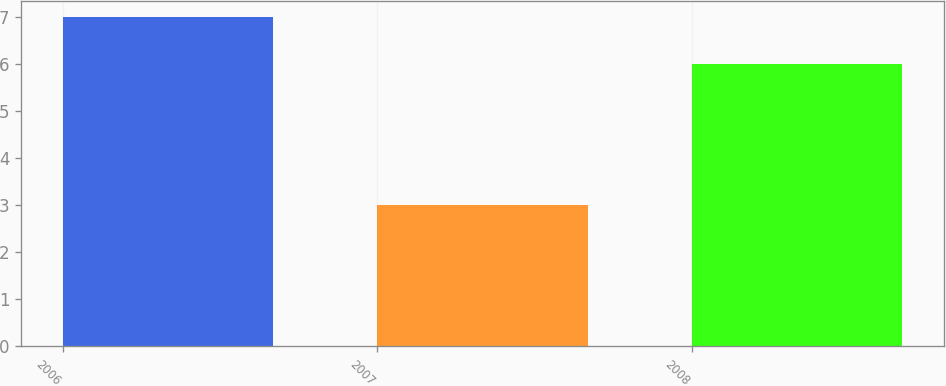Convert chart. <chart><loc_0><loc_0><loc_500><loc_500><bar_chart><fcel>2006<fcel>2007<fcel>2008<nl><fcel>7<fcel>3<fcel>6<nl></chart> 